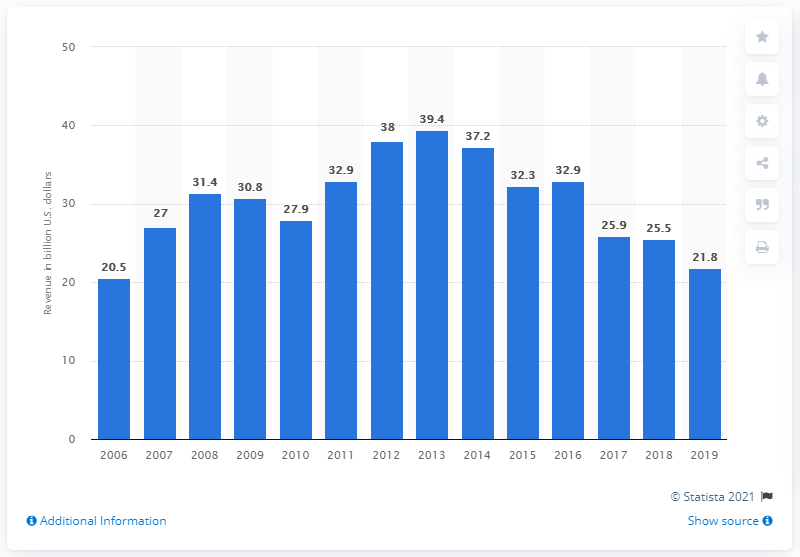Outline some significant characteristics in this image. Bechtel generated $21.8 billion in revenue during the fiscal year of 2019. In 2006, Bechtel's global revenue was first reported. 